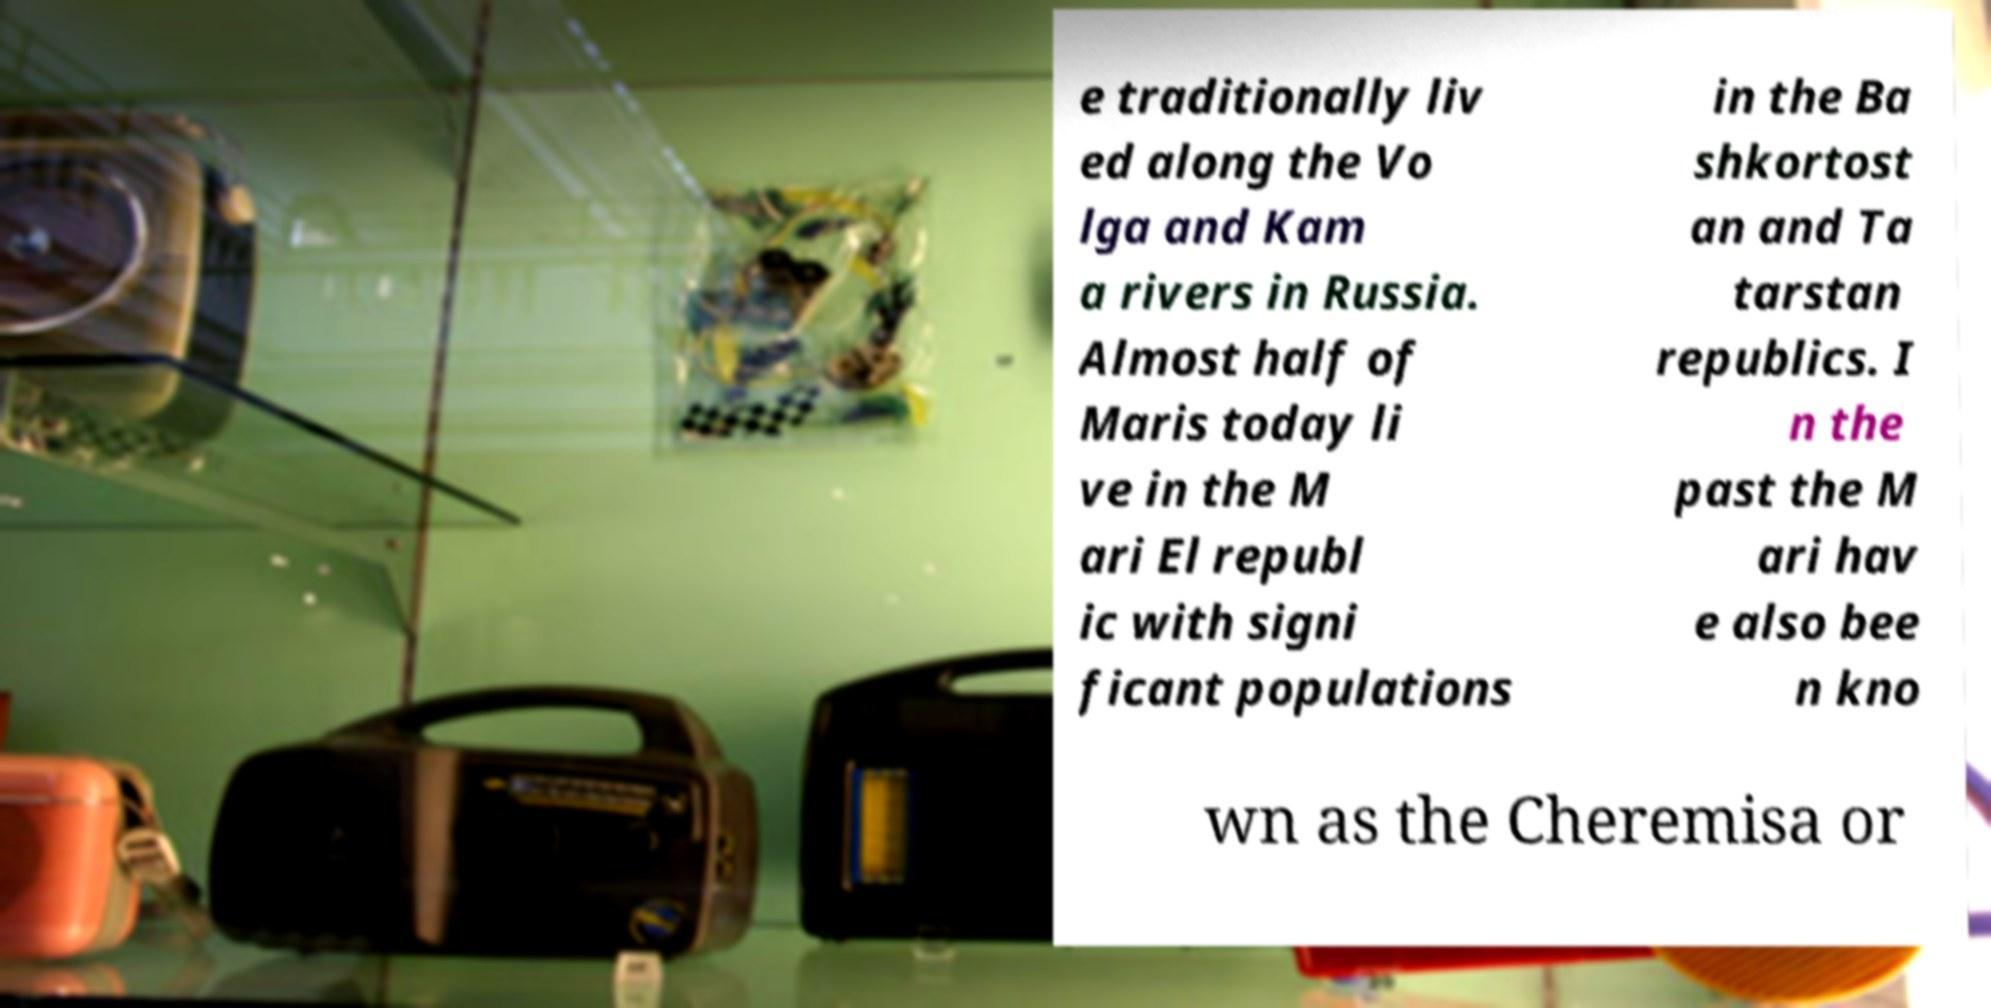Can you accurately transcribe the text from the provided image for me? e traditionally liv ed along the Vo lga and Kam a rivers in Russia. Almost half of Maris today li ve in the M ari El republ ic with signi ficant populations in the Ba shkortost an and Ta tarstan republics. I n the past the M ari hav e also bee n kno wn as the Cheremisa or 